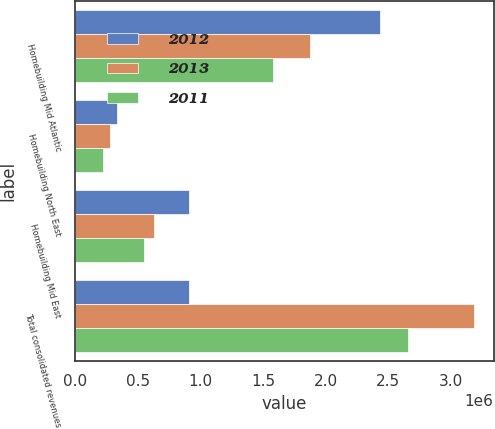Convert chart to OTSL. <chart><loc_0><loc_0><loc_500><loc_500><stacked_bar_chart><ecel><fcel>Homebuilding Mid Atlantic<fcel>Homebuilding North East<fcel>Homebuilding Mid East<fcel>Total consolidated revenues<nl><fcel>2012<fcel>2.43939e+06<fcel>332681<fcel>908198<fcel>908198<nl><fcel>2013<fcel>1.8779e+06<fcel>278715<fcel>630367<fcel>3.18465e+06<nl><fcel>2011<fcel>1.58283e+06<fcel>221146<fcel>549384<fcel>2.65915e+06<nl></chart> 